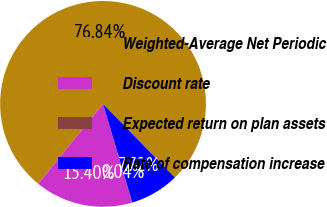Convert chart to OTSL. <chart><loc_0><loc_0><loc_500><loc_500><pie_chart><fcel>Weighted-Average Net Periodic<fcel>Discount rate<fcel>Expected return on plan assets<fcel>Rate of compensation increase<nl><fcel>76.84%<fcel>15.4%<fcel>0.04%<fcel>7.72%<nl></chart> 